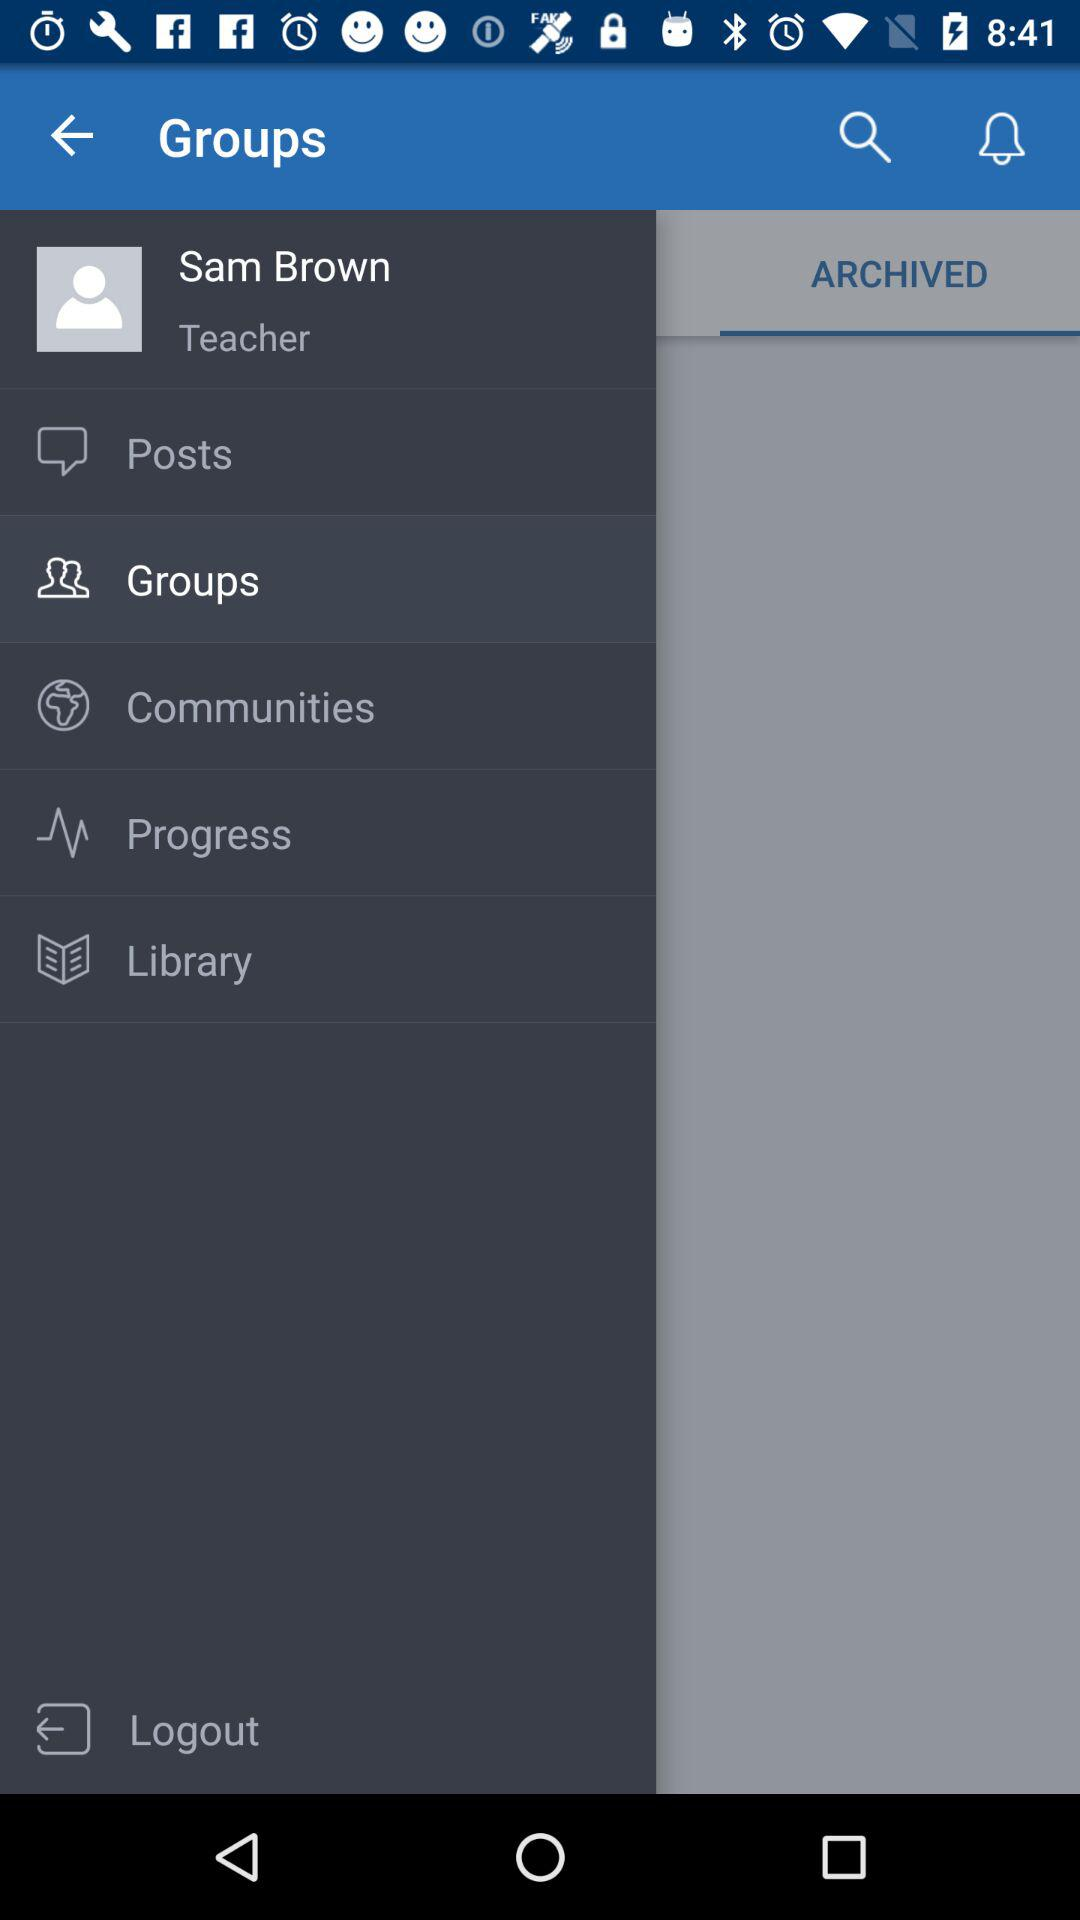What is the profession of the user? The profession is "Teacher". 